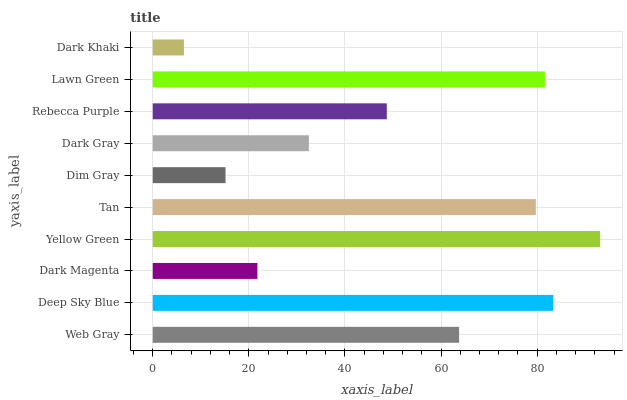Is Dark Khaki the minimum?
Answer yes or no. Yes. Is Yellow Green the maximum?
Answer yes or no. Yes. Is Deep Sky Blue the minimum?
Answer yes or no. No. Is Deep Sky Blue the maximum?
Answer yes or no. No. Is Deep Sky Blue greater than Web Gray?
Answer yes or no. Yes. Is Web Gray less than Deep Sky Blue?
Answer yes or no. Yes. Is Web Gray greater than Deep Sky Blue?
Answer yes or no. No. Is Deep Sky Blue less than Web Gray?
Answer yes or no. No. Is Web Gray the high median?
Answer yes or no. Yes. Is Rebecca Purple the low median?
Answer yes or no. Yes. Is Tan the high median?
Answer yes or no. No. Is Deep Sky Blue the low median?
Answer yes or no. No. 